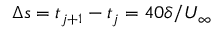Convert formula to latex. <formula><loc_0><loc_0><loc_500><loc_500>\Delta s = t _ { j + 1 } - t _ { j } = 4 0 \delta / U _ { \infty }</formula> 